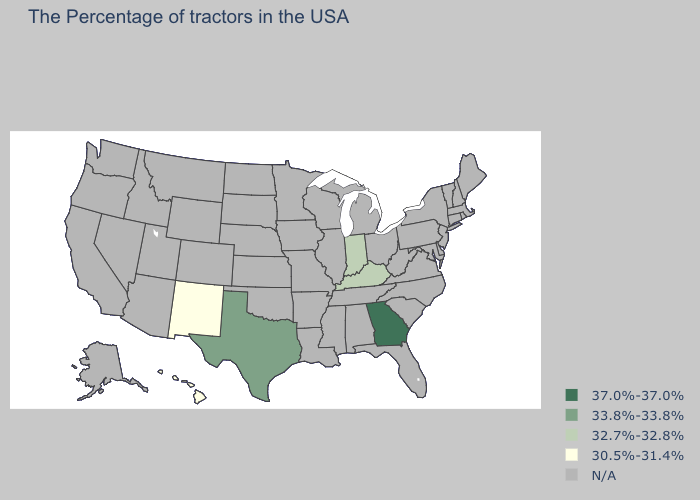What is the value of California?
Quick response, please. N/A. What is the value of Florida?
Be succinct. N/A. Does Hawaii have the highest value in the USA?
Be succinct. No. What is the value of New York?
Answer briefly. N/A. Which states have the highest value in the USA?
Short answer required. Georgia. Which states have the highest value in the USA?
Be succinct. Georgia. Does the map have missing data?
Keep it brief. Yes. What is the lowest value in the South?
Quick response, please. 32.7%-32.8%. What is the value of Pennsylvania?
Answer briefly. N/A. Name the states that have a value in the range 37.0%-37.0%?
Answer briefly. Georgia. Name the states that have a value in the range 32.7%-32.8%?
Answer briefly. Kentucky, Indiana. Does Texas have the lowest value in the South?
Quick response, please. No. 